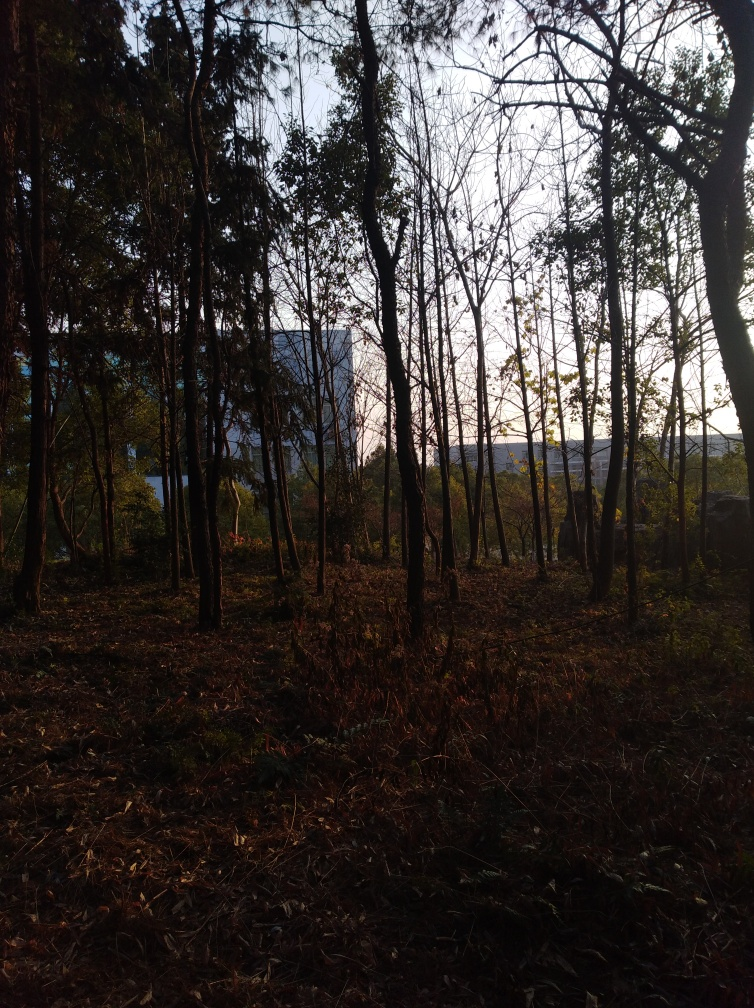What time of day does this image seem to represent? The shadows are long and the lighting has a golden quality to it, which indicates that the image likely represents the late afternoon or early evening hours, commonly referred to as the golden hour. This time of day is known for its warm, soft lighting conditions, which are highly valued in photography for the depth and dimension they can add to images. 